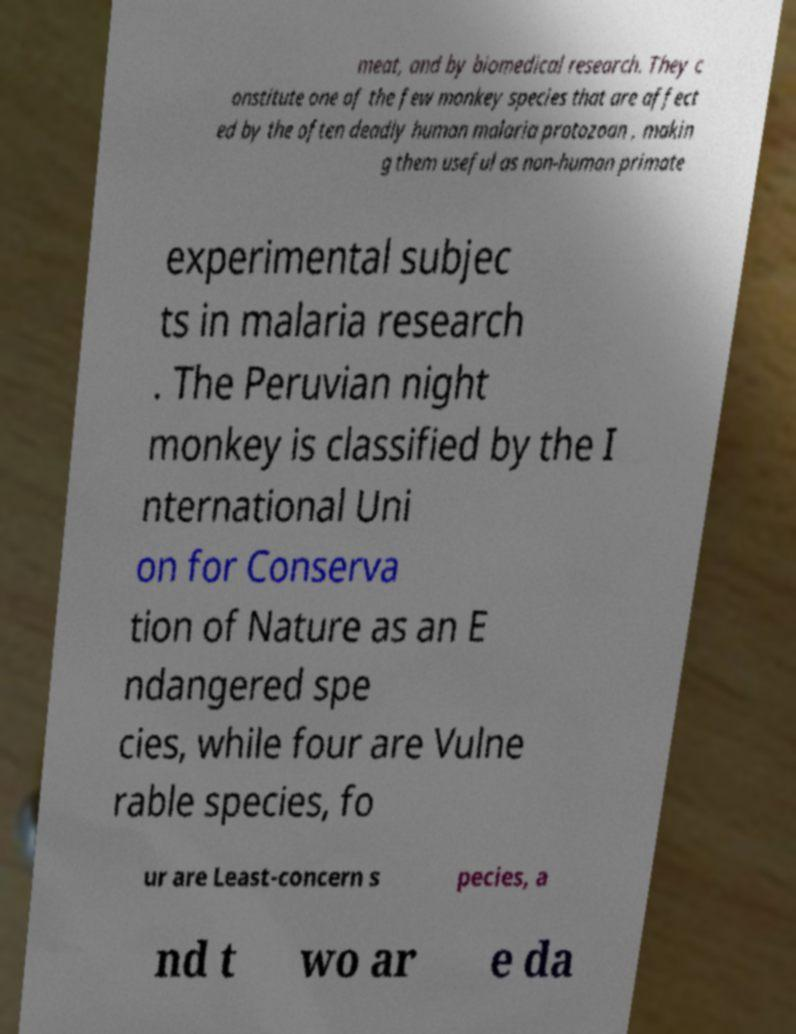Please read and relay the text visible in this image. What does it say? meat, and by biomedical research. They c onstitute one of the few monkey species that are affect ed by the often deadly human malaria protozoan , makin g them useful as non-human primate experimental subjec ts in malaria research . The Peruvian night monkey is classified by the I nternational Uni on for Conserva tion of Nature as an E ndangered spe cies, while four are Vulne rable species, fo ur are Least-concern s pecies, a nd t wo ar e da 